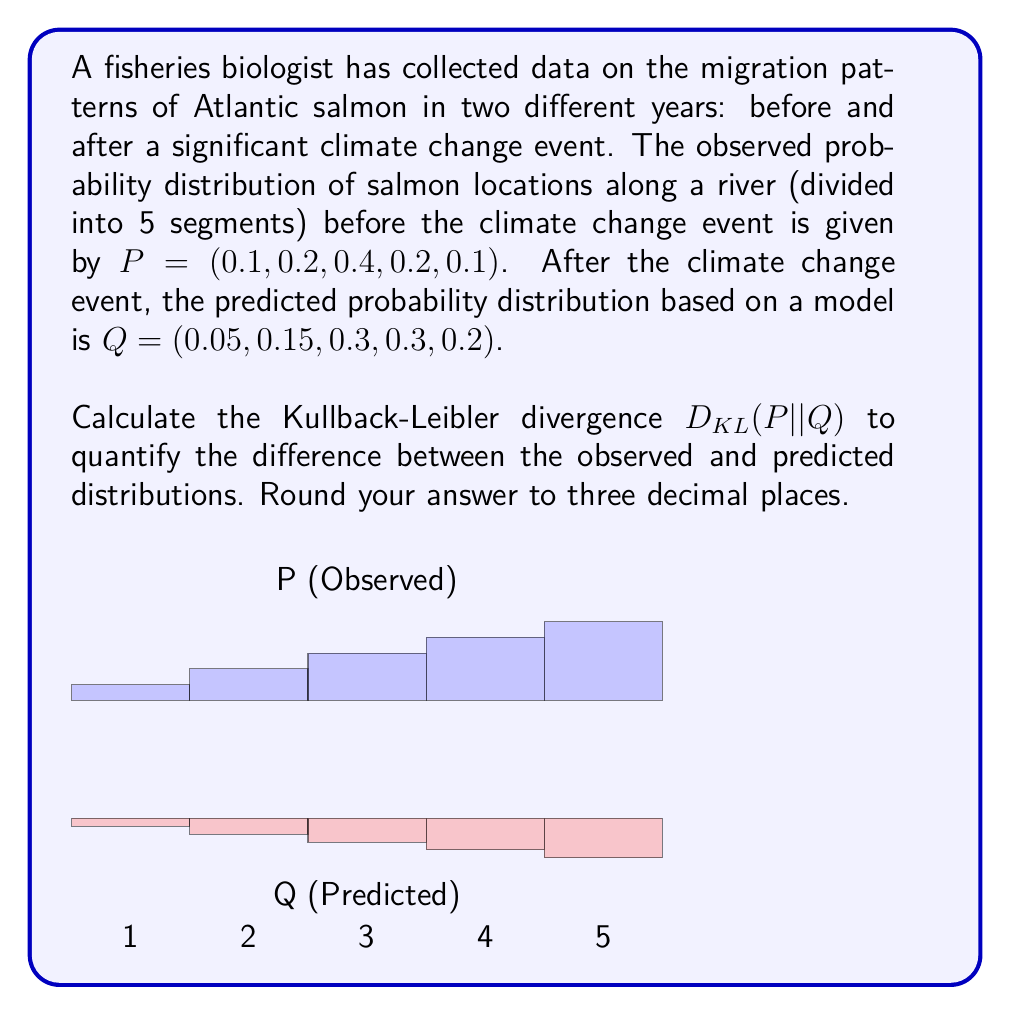Can you answer this question? To calculate the Kullback-Leibler divergence between the observed distribution $P$ and the predicted distribution $Q$, we use the formula:

$$D_{KL}(P||Q) = \sum_{i} P(i) \log\left(\frac{P(i)}{Q(i)}\right)$$

Let's calculate this step-by-step:

1) For each segment $i$, we need to calculate $P(i) \log\left(\frac{P(i)}{Q(i)}\right)$:

   Segment 1: $0.1 \log\left(\frac{0.1}{0.05}\right) = 0.1 \log(2) \approx 0.0693$
   Segment 2: $0.2 \log\left(\frac{0.2}{0.15}\right) \approx 0.0280$
   Segment 3: $0.4 \log\left(\frac{0.4}{0.3}\right) \approx 0.0365$
   Segment 4: $0.2 \log\left(\frac{0.2}{0.3}\right) \approx -0.0406$
   Segment 5: $0.1 \log\left(\frac{0.1}{0.2}\right) \approx -0.0693$

2) Now, we sum up all these values:

   $D_{KL}(P||Q) = 0.0693 + 0.0280 + 0.0365 - 0.0406 - 0.0693 = 0.0239$

3) Rounding to three decimal places:

   $D_{KL}(P||Q) \approx 0.024$

This value quantifies the information lost when the predicted distribution $Q$ is used to approximate the observed distribution $P$. A lower value indicates that the predicted distribution is closer to the observed distribution.
Answer: 0.024 